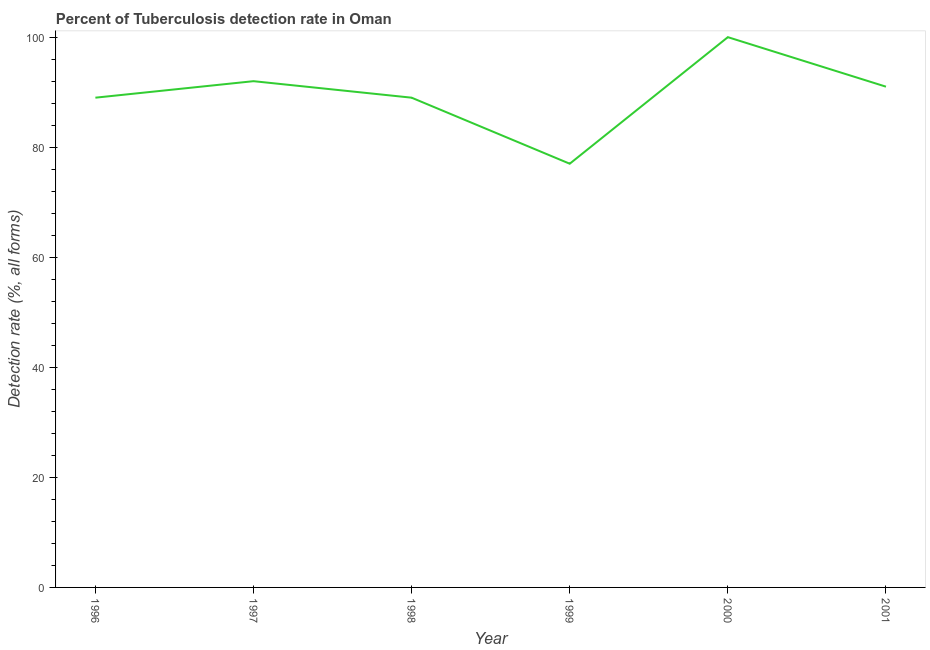What is the detection rate of tuberculosis in 2001?
Provide a succinct answer. 91. Across all years, what is the maximum detection rate of tuberculosis?
Offer a very short reply. 100. Across all years, what is the minimum detection rate of tuberculosis?
Make the answer very short. 77. In which year was the detection rate of tuberculosis maximum?
Ensure brevity in your answer.  2000. In which year was the detection rate of tuberculosis minimum?
Your answer should be very brief. 1999. What is the sum of the detection rate of tuberculosis?
Keep it short and to the point. 538. What is the average detection rate of tuberculosis per year?
Provide a short and direct response. 89.67. What is the median detection rate of tuberculosis?
Your response must be concise. 90. What is the ratio of the detection rate of tuberculosis in 1997 to that in 2000?
Offer a terse response. 0.92. What is the difference between the highest and the second highest detection rate of tuberculosis?
Ensure brevity in your answer.  8. Is the sum of the detection rate of tuberculosis in 1998 and 1999 greater than the maximum detection rate of tuberculosis across all years?
Provide a short and direct response. Yes. What is the difference between the highest and the lowest detection rate of tuberculosis?
Keep it short and to the point. 23. How many lines are there?
Make the answer very short. 1. What is the difference between two consecutive major ticks on the Y-axis?
Give a very brief answer. 20. Are the values on the major ticks of Y-axis written in scientific E-notation?
Your response must be concise. No. Does the graph contain grids?
Ensure brevity in your answer.  No. What is the title of the graph?
Give a very brief answer. Percent of Tuberculosis detection rate in Oman. What is the label or title of the Y-axis?
Offer a terse response. Detection rate (%, all forms). What is the Detection rate (%, all forms) in 1996?
Make the answer very short. 89. What is the Detection rate (%, all forms) in 1997?
Ensure brevity in your answer.  92. What is the Detection rate (%, all forms) in 1998?
Offer a terse response. 89. What is the Detection rate (%, all forms) of 1999?
Your answer should be compact. 77. What is the Detection rate (%, all forms) in 2001?
Your response must be concise. 91. What is the difference between the Detection rate (%, all forms) in 1996 and 1997?
Ensure brevity in your answer.  -3. What is the difference between the Detection rate (%, all forms) in 1996 and 1998?
Offer a very short reply. 0. What is the difference between the Detection rate (%, all forms) in 1996 and 2000?
Provide a succinct answer. -11. What is the difference between the Detection rate (%, all forms) in 1996 and 2001?
Your response must be concise. -2. What is the difference between the Detection rate (%, all forms) in 1997 and 1998?
Your answer should be compact. 3. What is the difference between the Detection rate (%, all forms) in 1997 and 1999?
Ensure brevity in your answer.  15. What is the difference between the Detection rate (%, all forms) in 1997 and 2001?
Offer a terse response. 1. What is the difference between the Detection rate (%, all forms) in 1998 and 2001?
Make the answer very short. -2. What is the difference between the Detection rate (%, all forms) in 2000 and 2001?
Your answer should be compact. 9. What is the ratio of the Detection rate (%, all forms) in 1996 to that in 1999?
Your answer should be very brief. 1.16. What is the ratio of the Detection rate (%, all forms) in 1996 to that in 2000?
Ensure brevity in your answer.  0.89. What is the ratio of the Detection rate (%, all forms) in 1996 to that in 2001?
Offer a very short reply. 0.98. What is the ratio of the Detection rate (%, all forms) in 1997 to that in 1998?
Make the answer very short. 1.03. What is the ratio of the Detection rate (%, all forms) in 1997 to that in 1999?
Keep it short and to the point. 1.2. What is the ratio of the Detection rate (%, all forms) in 1997 to that in 2000?
Your answer should be very brief. 0.92. What is the ratio of the Detection rate (%, all forms) in 1998 to that in 1999?
Ensure brevity in your answer.  1.16. What is the ratio of the Detection rate (%, all forms) in 1998 to that in 2000?
Your answer should be compact. 0.89. What is the ratio of the Detection rate (%, all forms) in 1998 to that in 2001?
Provide a short and direct response. 0.98. What is the ratio of the Detection rate (%, all forms) in 1999 to that in 2000?
Keep it short and to the point. 0.77. What is the ratio of the Detection rate (%, all forms) in 1999 to that in 2001?
Offer a very short reply. 0.85. What is the ratio of the Detection rate (%, all forms) in 2000 to that in 2001?
Keep it short and to the point. 1.1. 